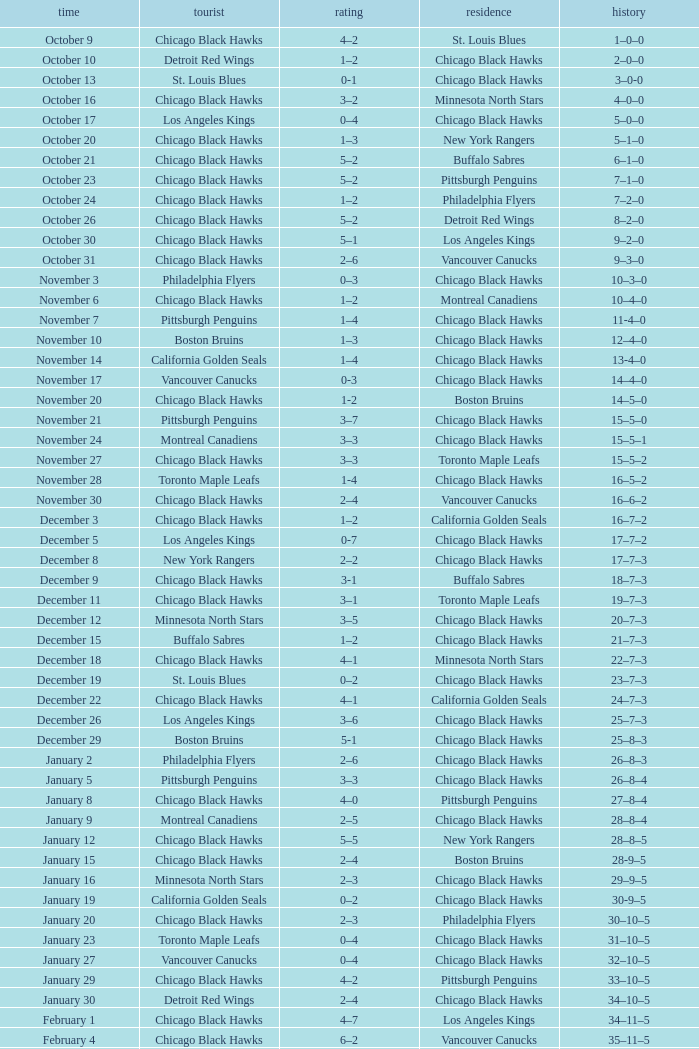What is the Record of the February 26 date? 39–16–7. 